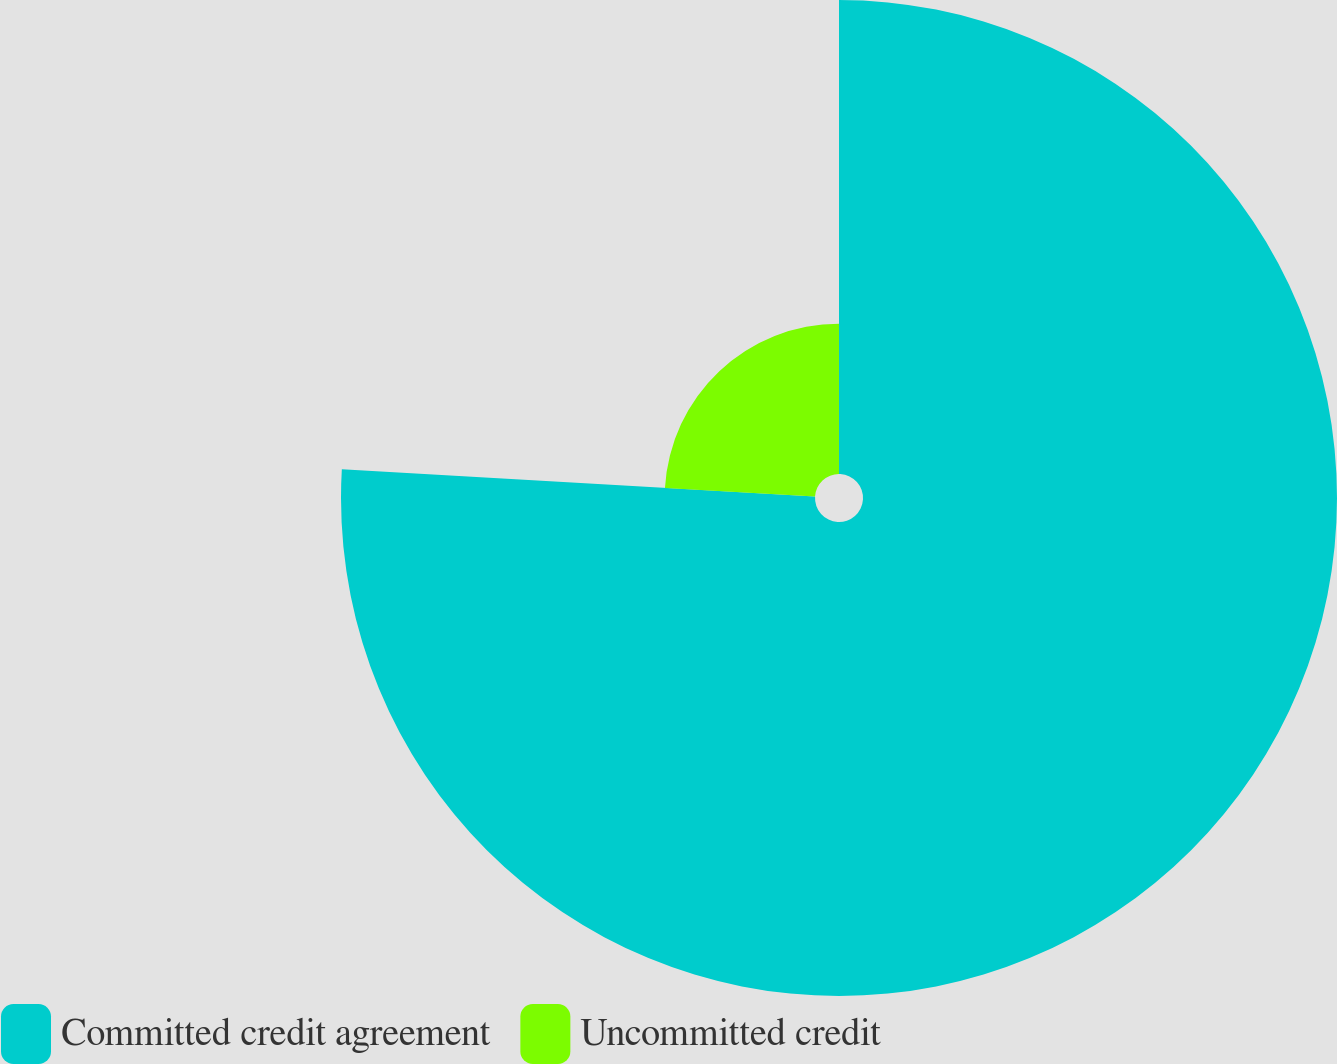<chart> <loc_0><loc_0><loc_500><loc_500><pie_chart><fcel>Committed credit agreement<fcel>Uncommitted credit<nl><fcel>75.92%<fcel>24.08%<nl></chart> 